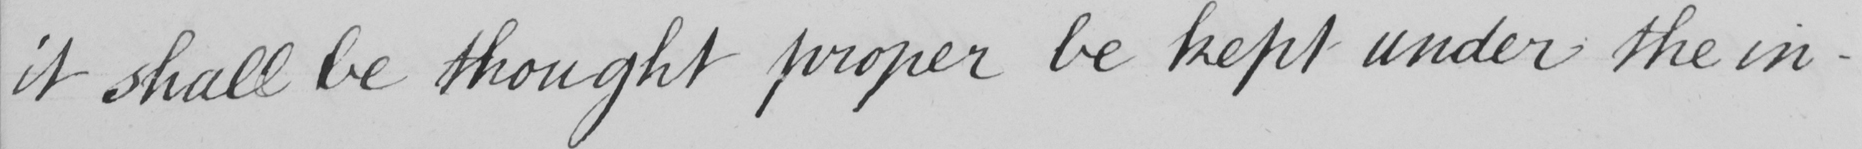Can you tell me what this handwritten text says? it shall be thought proper be kept under the in- 